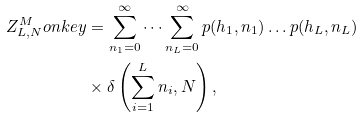<formula> <loc_0><loc_0><loc_500><loc_500>Z _ { L , N } ^ { M } o n k e y & = \sum _ { n _ { 1 } = 0 } ^ { \infty } \dots \sum _ { n _ { L } = 0 } ^ { \infty } p ( h _ { 1 } , n _ { 1 } ) \dots p ( h _ { L } , n _ { L } ) \\ & \times \delta \left ( \sum _ { i = 1 } ^ { L } n _ { i } , N \right ) ,</formula> 